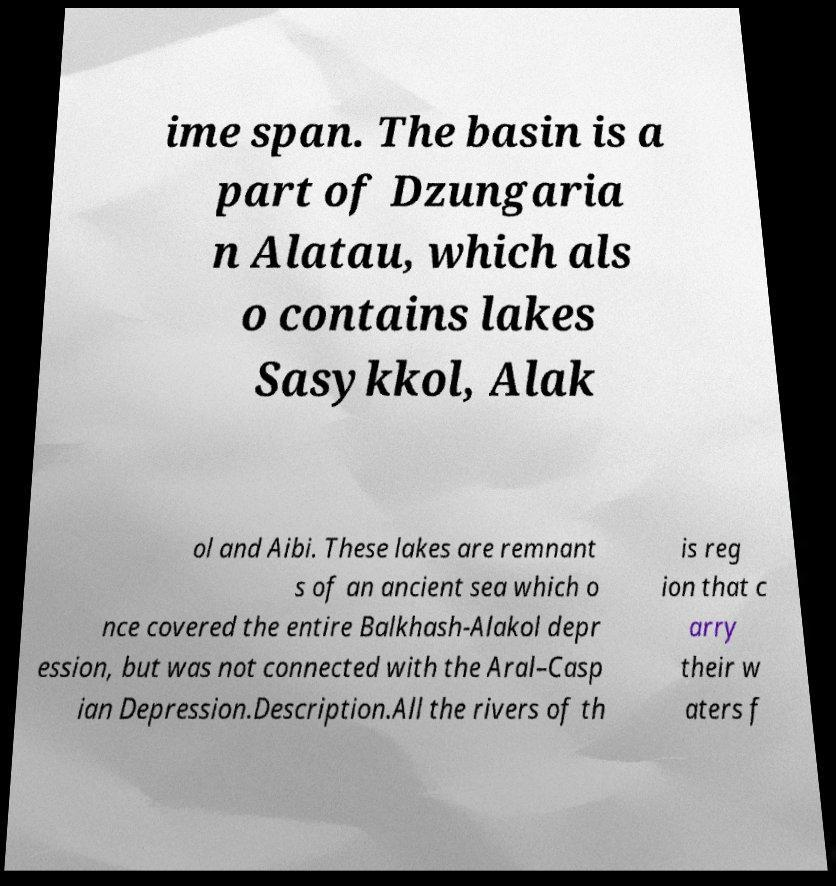For documentation purposes, I need the text within this image transcribed. Could you provide that? ime span. The basin is a part of Dzungaria n Alatau, which als o contains lakes Sasykkol, Alak ol and Aibi. These lakes are remnant s of an ancient sea which o nce covered the entire Balkhash-Alakol depr ession, but was not connected with the Aral–Casp ian Depression.Description.All the rivers of th is reg ion that c arry their w aters f 